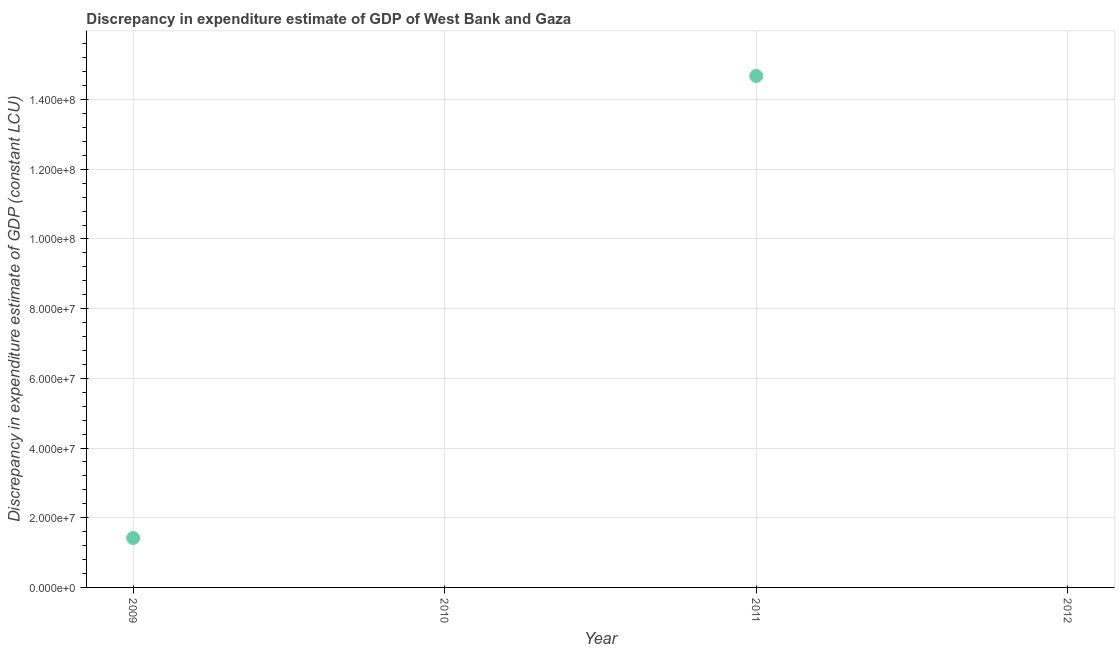What is the discrepancy in expenditure estimate of gdp in 2011?
Your response must be concise. 1.47e+08. Across all years, what is the maximum discrepancy in expenditure estimate of gdp?
Your answer should be very brief. 1.47e+08. What is the sum of the discrepancy in expenditure estimate of gdp?
Provide a short and direct response. 1.61e+08. What is the average discrepancy in expenditure estimate of gdp per year?
Make the answer very short. 4.02e+07. What is the median discrepancy in expenditure estimate of gdp?
Make the answer very short. 7.09e+06. In how many years, is the discrepancy in expenditure estimate of gdp greater than 60000000 LCU?
Provide a short and direct response. 1. Is the difference between the discrepancy in expenditure estimate of gdp in 2009 and 2011 greater than the difference between any two years?
Provide a succinct answer. No. What is the difference between the highest and the lowest discrepancy in expenditure estimate of gdp?
Offer a very short reply. 1.47e+08. Does the discrepancy in expenditure estimate of gdp monotonically increase over the years?
Provide a succinct answer. No. How many years are there in the graph?
Offer a very short reply. 4. What is the difference between two consecutive major ticks on the Y-axis?
Keep it short and to the point. 2.00e+07. Are the values on the major ticks of Y-axis written in scientific E-notation?
Offer a terse response. Yes. What is the title of the graph?
Offer a terse response. Discrepancy in expenditure estimate of GDP of West Bank and Gaza. What is the label or title of the Y-axis?
Provide a short and direct response. Discrepancy in expenditure estimate of GDP (constant LCU). What is the Discrepancy in expenditure estimate of GDP (constant LCU) in 2009?
Your answer should be very brief. 1.42e+07. What is the Discrepancy in expenditure estimate of GDP (constant LCU) in 2010?
Provide a short and direct response. 0. What is the Discrepancy in expenditure estimate of GDP (constant LCU) in 2011?
Provide a short and direct response. 1.47e+08. What is the difference between the Discrepancy in expenditure estimate of GDP (constant LCU) in 2009 and 2011?
Offer a very short reply. -1.33e+08. What is the ratio of the Discrepancy in expenditure estimate of GDP (constant LCU) in 2009 to that in 2011?
Your response must be concise. 0.1. 